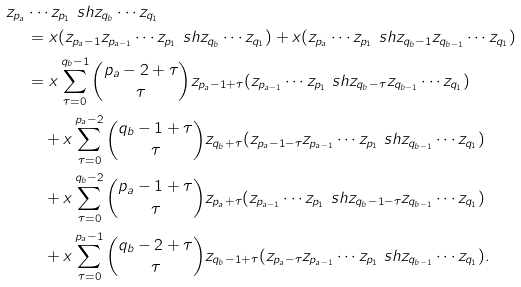Convert formula to latex. <formula><loc_0><loc_0><loc_500><loc_500>z _ { p _ { a } } & \cdots z _ { p _ { 1 } } \ s h z _ { q _ { b } } \cdots z _ { q _ { 1 } } \\ & = x ( z _ { p _ { a } - 1 } z _ { p _ { a - 1 } } \cdots z _ { p _ { 1 } } \ s h z _ { q _ { b } } \cdots z _ { q _ { 1 } } ) + x ( z _ { p _ { a } } \cdots z _ { p _ { 1 } } \ s h z _ { q _ { b } - 1 } z _ { q _ { b - 1 } } \cdots z _ { q _ { 1 } } ) \\ & = x \sum _ { \tau = 0 } ^ { q _ { b } - 1 } \binom { p _ { a } - 2 + \tau } { \tau } z _ { p _ { a } - 1 + \tau } ( z _ { p _ { a - 1 } } \cdots z _ { p _ { 1 } } \ s h z _ { q _ { b } - \tau } z _ { q _ { b - 1 } } \cdots z _ { q _ { 1 } } ) \\ & \quad + x \sum _ { \tau = 0 } ^ { p _ { a } - 2 } \binom { q _ { b } - 1 + \tau } { \tau } z _ { q _ { b } + \tau } ( z _ { p _ { a } - 1 - \tau } z _ { p _ { a - 1 } } \cdots z _ { p _ { 1 } } \ s h z _ { q _ { b - 1 } } \cdots z _ { q _ { 1 } } ) \\ & \quad + x \sum _ { \tau = 0 } ^ { q _ { b } - 2 } \binom { p _ { a } - 1 + \tau } { \tau } z _ { p _ { a } + \tau } ( z _ { p _ { a - 1 } } \cdots z _ { p _ { 1 } } \ s h z _ { q _ { b } - 1 - \tau } z _ { q _ { b - 1 } } \cdots z _ { q _ { 1 } } ) \\ & \quad + x \sum _ { \tau = 0 } ^ { p _ { a } - 1 } \binom { q _ { b } - 2 + \tau } { \tau } z _ { q _ { b } - 1 + \tau } ( z _ { p _ { a } - \tau } z _ { p _ { a - 1 } } \cdots z _ { p _ { 1 } } \ s h z _ { q _ { b - 1 } } \cdots z _ { q _ { 1 } } ) .</formula> 